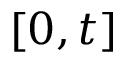Convert formula to latex. <formula><loc_0><loc_0><loc_500><loc_500>[ 0 , t ]</formula> 